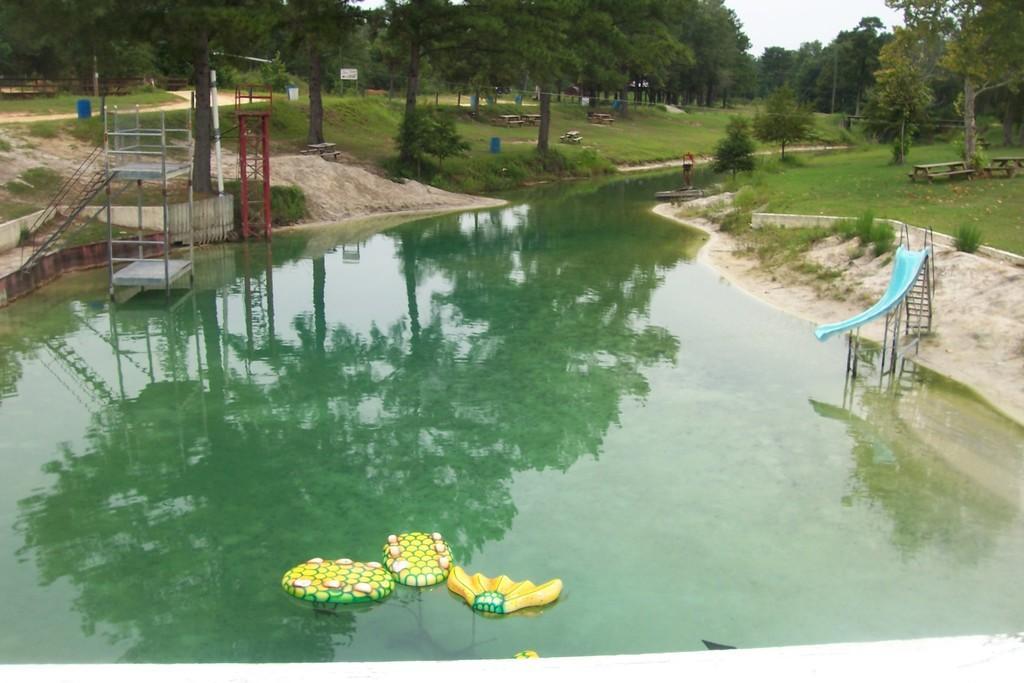How would you summarize this image in a sentence or two? In this image I can see few trees,water,poles,ladder,benches,tables,blue slide,few colorful objects on the water and fencing. The sky is in white color. 